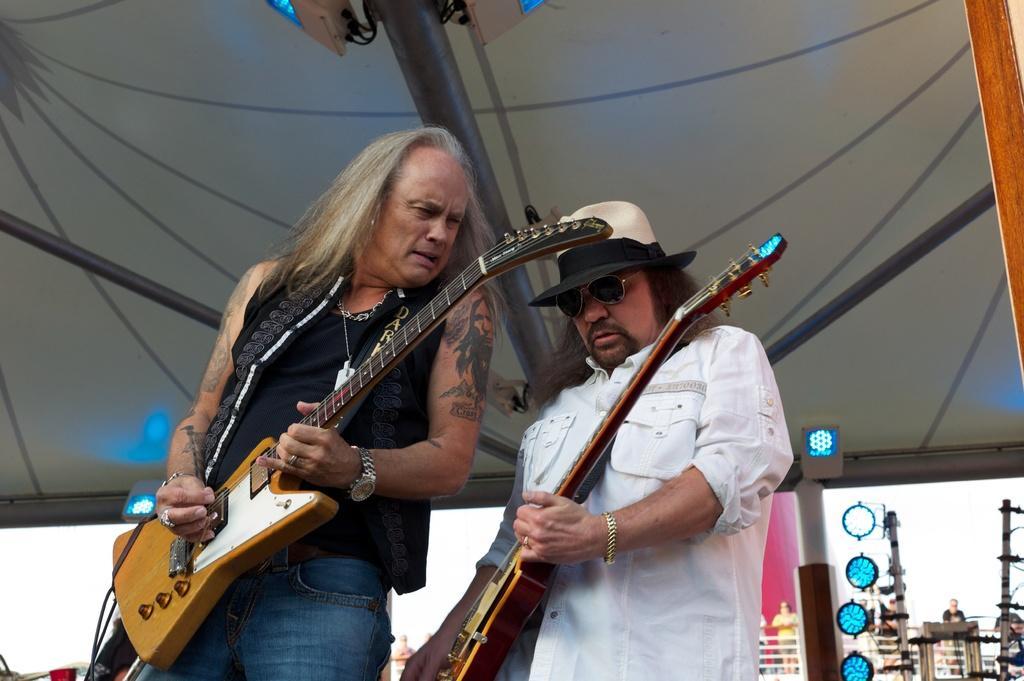Can you describe this image briefly? In this image, there are two persons standing and playing a guitar. A roof top is grey in color on which pole is mounted. In the background poles are visible and a person is standing in front of that. And a sky is visible on both side of the image. It looks as if the image is taken inside a boat. 